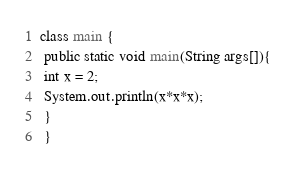Convert code to text. <code><loc_0><loc_0><loc_500><loc_500><_Java_>class main {
 public static void main(String args[]){
 int x = 2;
 System.out.println(x*x*x);
 }
 }</code> 